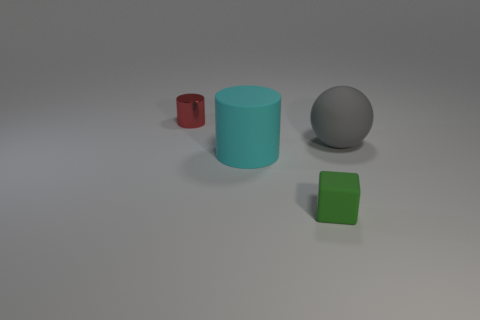Is there any other thing that has the same shape as the small green object?
Make the answer very short. No. What material is the big object to the left of the gray matte sphere that is behind the large cyan thing?
Your response must be concise. Rubber. Are there any small red spheres that have the same material as the tiny red thing?
Offer a very short reply. No. What material is the red object that is the same size as the matte block?
Keep it short and to the point. Metal. What size is the thing that is left of the big object that is in front of the large rubber object right of the green matte block?
Keep it short and to the point. Small. Is there a small green rubber cube on the left side of the small object on the right side of the shiny cylinder?
Keep it short and to the point. No. Do the red shiny thing and the big object that is on the left side of the tiny matte cube have the same shape?
Your response must be concise. Yes. There is a ball behind the small block; what color is it?
Keep it short and to the point. Gray. How big is the cylinder in front of the small object behind the small block?
Your response must be concise. Large. Does the big rubber object that is in front of the big rubber ball have the same shape as the tiny red object?
Your answer should be compact. Yes. 